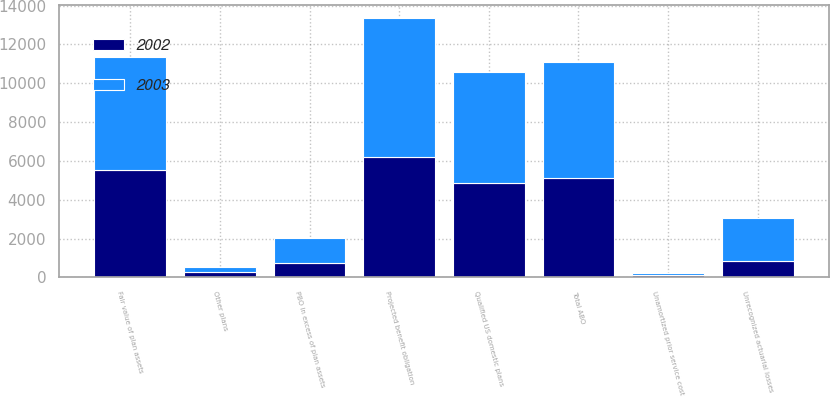Convert chart. <chart><loc_0><loc_0><loc_500><loc_500><stacked_bar_chart><ecel><fcel>Qualified US domestic plans<fcel>Other plans<fcel>Total ABO<fcel>Projected benefit obligation<fcel>Fair value of plan assets<fcel>PBO in excess of plan assets<fcel>Unrecognized actuarial losses<fcel>Unamortized prior service cost<nl><fcel>2003<fcel>5725<fcel>284<fcel>6009<fcel>7117<fcel>5825<fcel>1292<fcel>2247<fcel>116<nl><fcel>2002<fcel>4844<fcel>253<fcel>5097<fcel>6227<fcel>5510<fcel>717<fcel>823<fcel>122<nl></chart> 